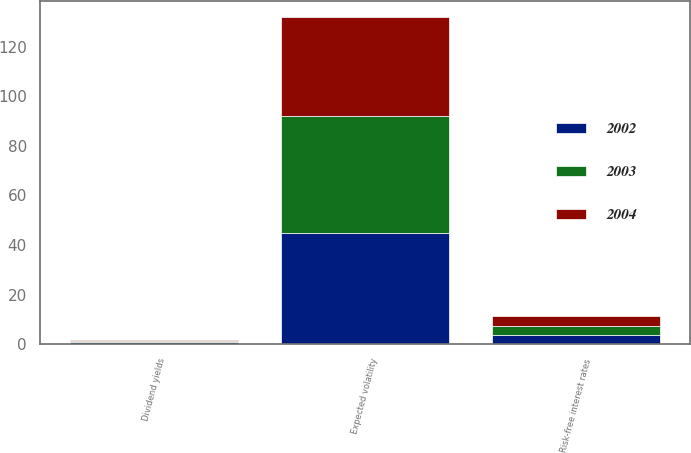<chart> <loc_0><loc_0><loc_500><loc_500><stacked_bar_chart><ecel><fcel>Risk-free interest rates<fcel>Expected volatility<fcel>Dividend yields<nl><fcel>2003<fcel>3.75<fcel>47<fcel>0.44<nl><fcel>2004<fcel>3.75<fcel>40<fcel>0.6<nl><fcel>2002<fcel>3.75<fcel>45<fcel>0.7<nl></chart> 